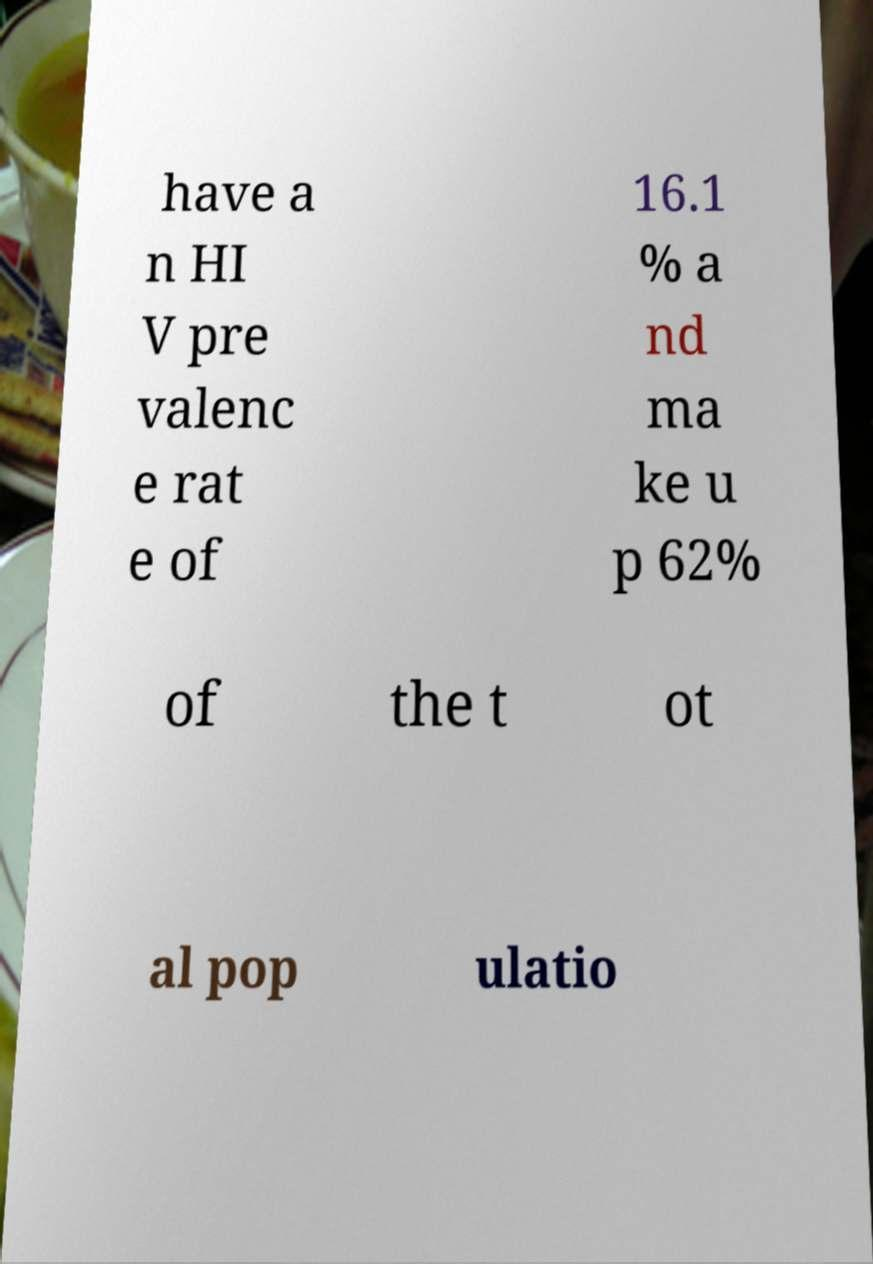Please identify and transcribe the text found in this image. have a n HI V pre valenc e rat e of 16.1 % a nd ma ke u p 62% of the t ot al pop ulatio 